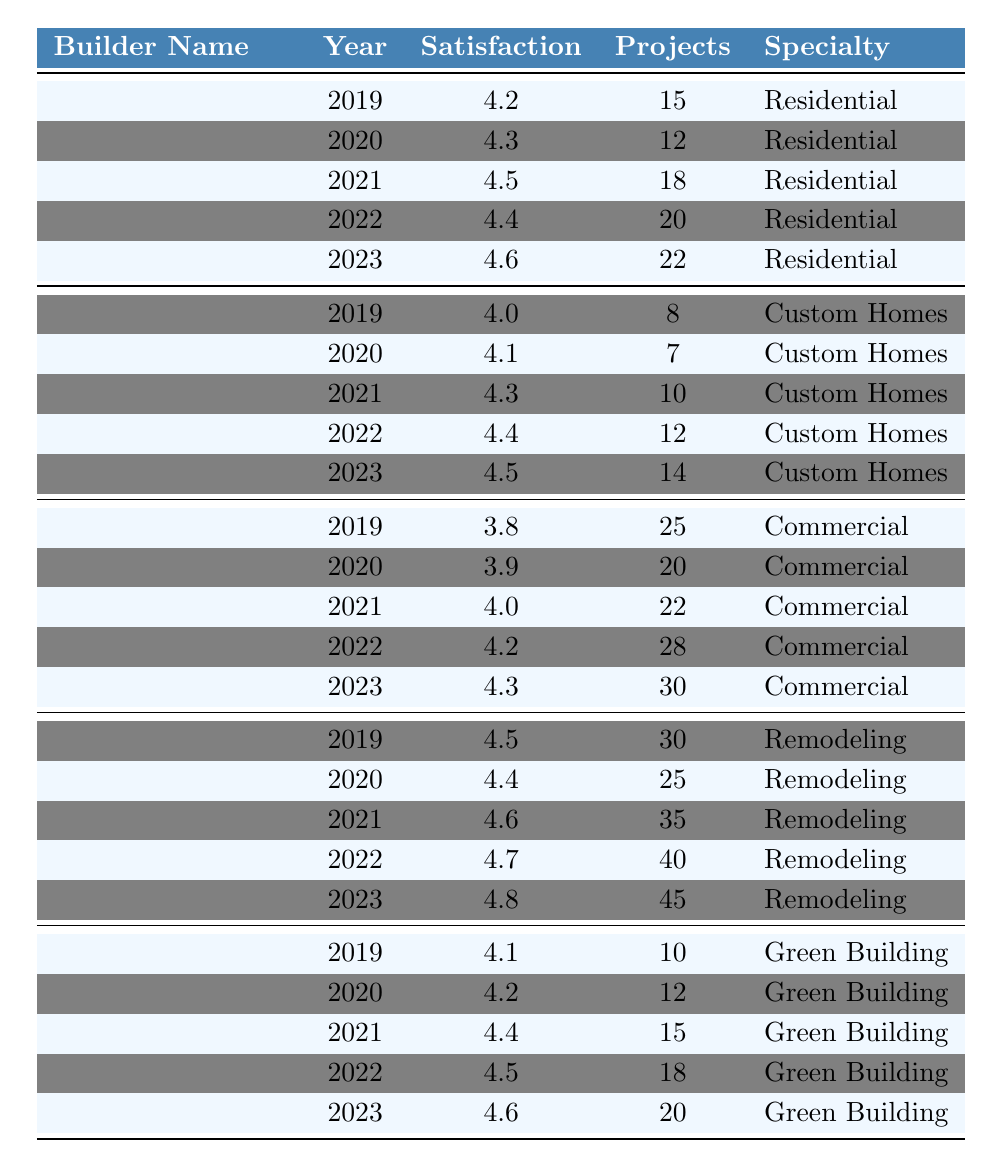What was the customer satisfaction rating for Ione Construction Services in 2023? Referencing the table, Ione Construction Services has a satisfaction rating of 4.6 in the year 2023.
Answer: 4.6 Which builder completed the most projects in 2022? According to the table, Heppner Home Improvements completed 40 projects in 2022, which is the highest among all builders.
Answer: Heppner Home Improvements What is the average customer satisfaction rating for Willow Creek Builders over the past 5 years? The ratings over the years from 2019 to 2023 for Willow Creek Builders are 4.0, 4.1, 4.3, 4.4, and 4.5. Sum these ratings: 4.0 + 4.1 + 4.3 + 4.4 + 4.5 = 21.3. There are 5 ratings, so the average is 21.3 / 5 = 4.26.
Answer: 4.26 Did Blue Mountain Contractors' customer satisfaction rating improve from 2019 to 2023? In 2019, the rating was 3.8, and in 2023, it increased to 4.3. Since 4.3 is greater than 3.8, the satisfaction rating improved over the years.
Answer: Yes Which builder had the highest customer satisfaction rating in 2021? In 2021, customer satisfaction ratings were: Ione Construction Services with 4.5, Willow Creek Builders with 4.3, Blue Mountain Contractors with 4.0, Heppner Home Improvements with 4.6, and Morrow County Craftsmen with 4.4. Heppner Home Improvements had the highest rating of 4.6.
Answer: Heppner Home Improvements What is the trend in customer satisfaction ratings for Heppner Home Improvements from 2019 to 2023? The ratings for Heppner Home Improvements from 2019 to 2023 are 4.5, 4.4, 4.6, 4.7, and 4.8, respectively. These values show a steady increase over the years, indicating a positive trend.
Answer: Increasing What was the difference in customer satisfaction ratings for Morrow County Craftsmen between 2019 and 2023? The customer satisfaction rating for Morrow County Craftsmen in 2019 was 4.1 and in 2023 was 4.6. The difference is calculated by subtracting the 2019 rating from the 2023 rating: 4.6 - 4.1 = 0.5.
Answer: 0.5 Which specialty had the lowest customer satisfaction rating in 2020? In 2020, the customer satisfaction ratings by specialty were: Residential (4.3, Ione Construction Services), Custom Homes (4.1, Willow Creek Builders), Commercial (3.9, Blue Mountain Contractors), Remodeling (4.4, Heppner Home Improvements), and Green Building (4.2, Morrow County Craftsmen). The lowest rating is 3.9 for Commercial.
Answer: Commercial Over the last 5 years, which builder showed the most consistent satisfaction rating? To determine this, we look for the builder with the smallest range of ratings. Ione Construction Services had ratings: 4.2, 4.3, 4.5, 4.4, 4.6 (range = 0.4), Heppner Home Improvements had ratings: 4.5, 4.4, 4.6, 4.7, 4.8 (range = 0.3). Thus, Heppner Home Improvements had the most consistent ratings with the smallest range.
Answer: Heppner Home Improvements 